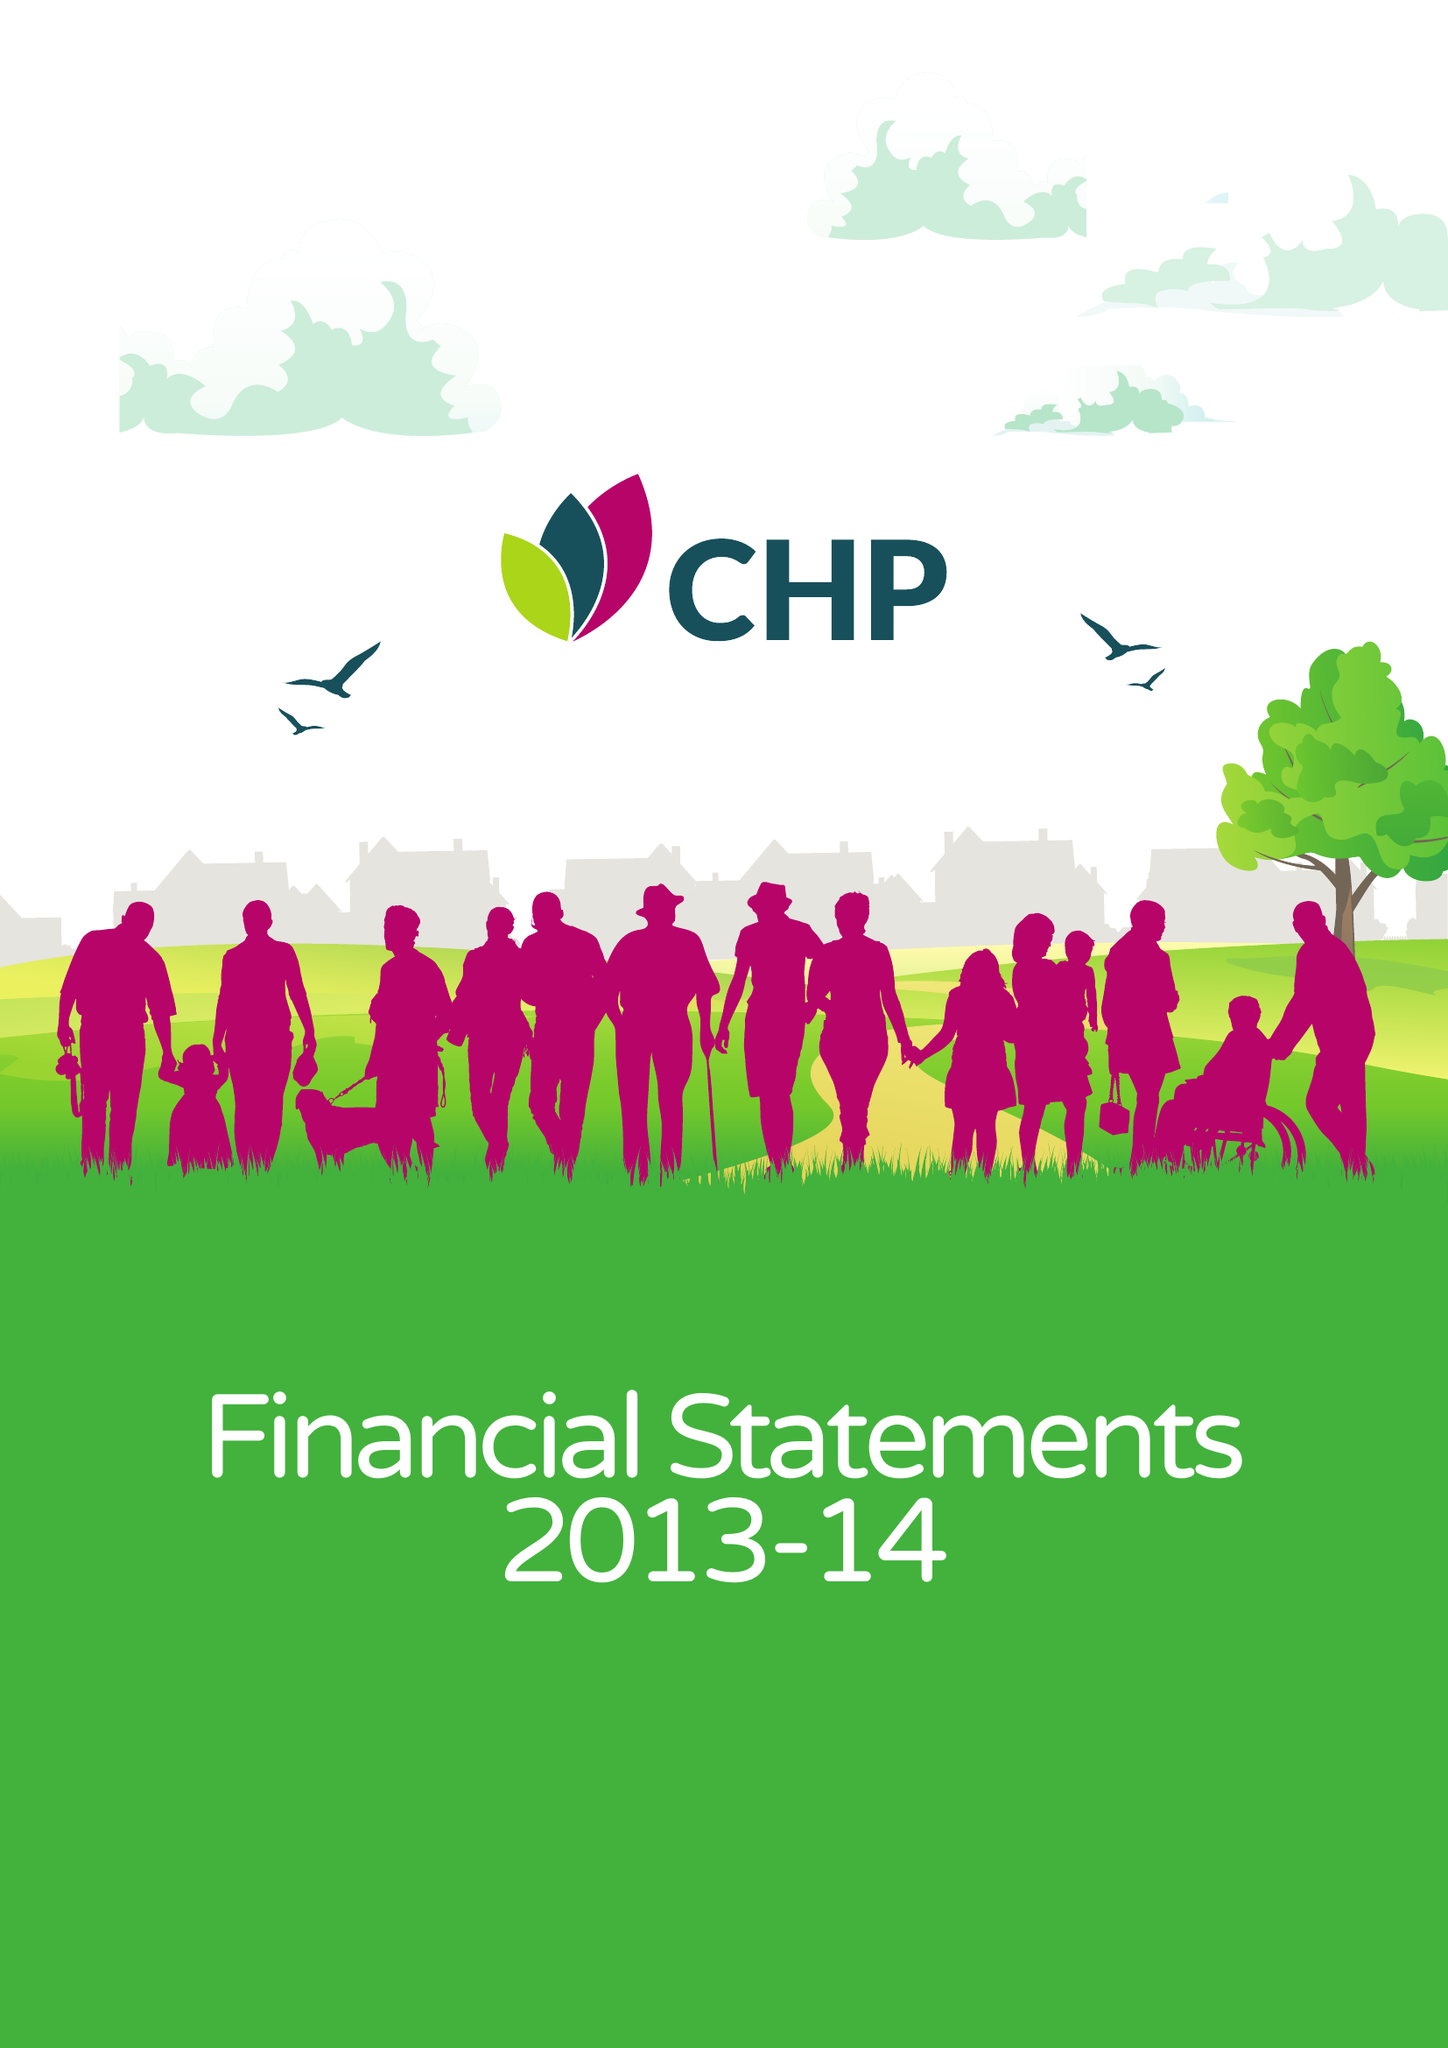What is the value for the spending_annually_in_british_pounds?
Answer the question using a single word or phrase. 42137000.00 